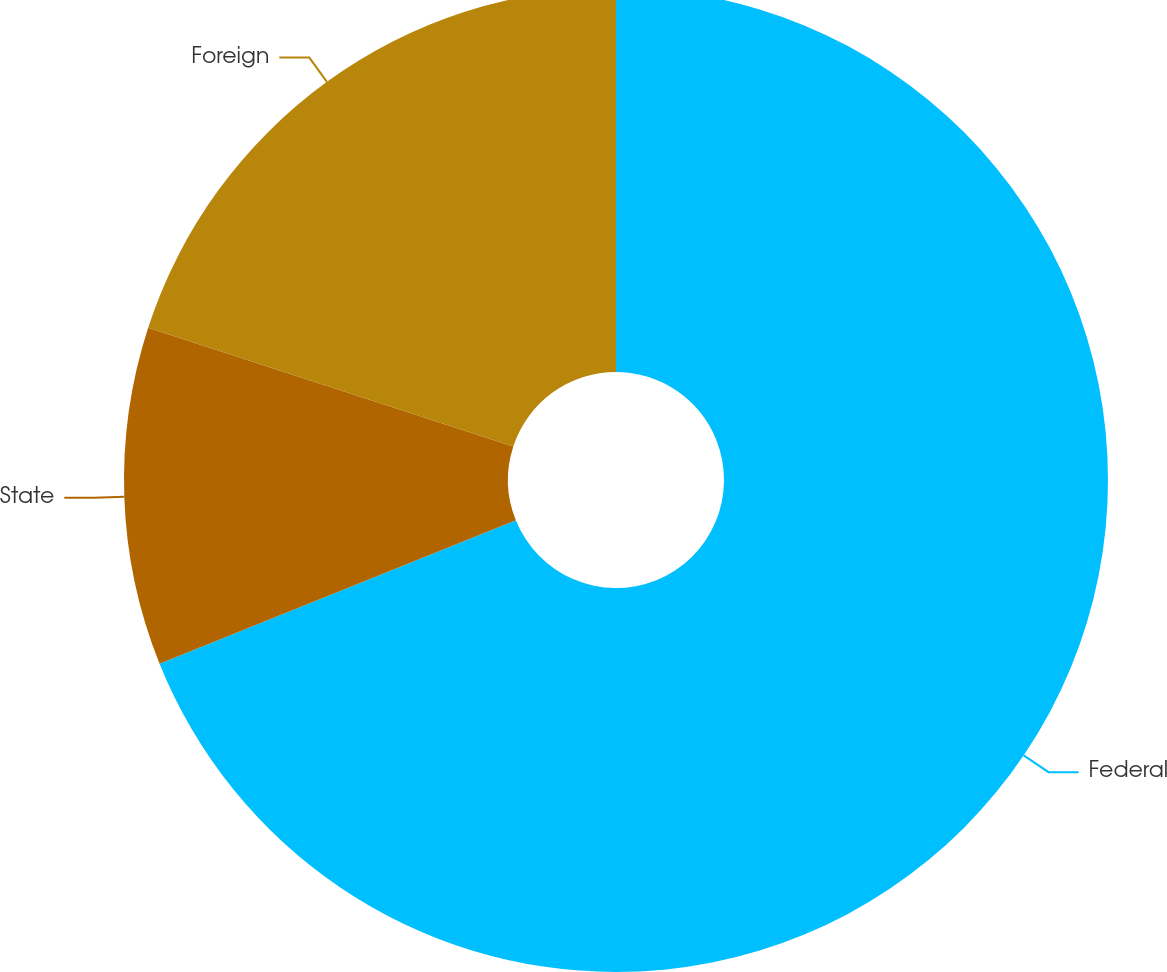Convert chart. <chart><loc_0><loc_0><loc_500><loc_500><pie_chart><fcel>Federal<fcel>State<fcel>Foreign<nl><fcel>68.91%<fcel>11.1%<fcel>19.99%<nl></chart> 